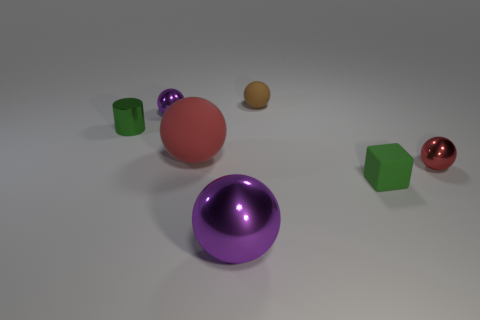There is a small rubber cube; is it the same color as the tiny cylinder that is to the left of the large red rubber thing?
Provide a short and direct response. Yes. Is the number of green matte blocks in front of the tiny purple metallic ball greater than the number of big brown matte cubes?
Your answer should be very brief. Yes. How many things are green blocks that are right of the big red object or green objects that are in front of the tiny green shiny object?
Your answer should be very brief. 1. There is a green object that is the same material as the brown sphere; what is its size?
Keep it short and to the point. Small. There is a purple metallic object in front of the small purple thing; is its shape the same as the green metal thing?
Your response must be concise. No. How many red things are small spheres or blocks?
Make the answer very short. 1. What number of other objects are the same shape as the brown thing?
Ensure brevity in your answer.  4. What shape is the metal object that is both in front of the cylinder and behind the big purple thing?
Your answer should be very brief. Sphere. Are there any purple spheres behind the small metal cylinder?
Your answer should be compact. Yes. The brown object that is the same shape as the big purple shiny thing is what size?
Your answer should be compact. Small. 